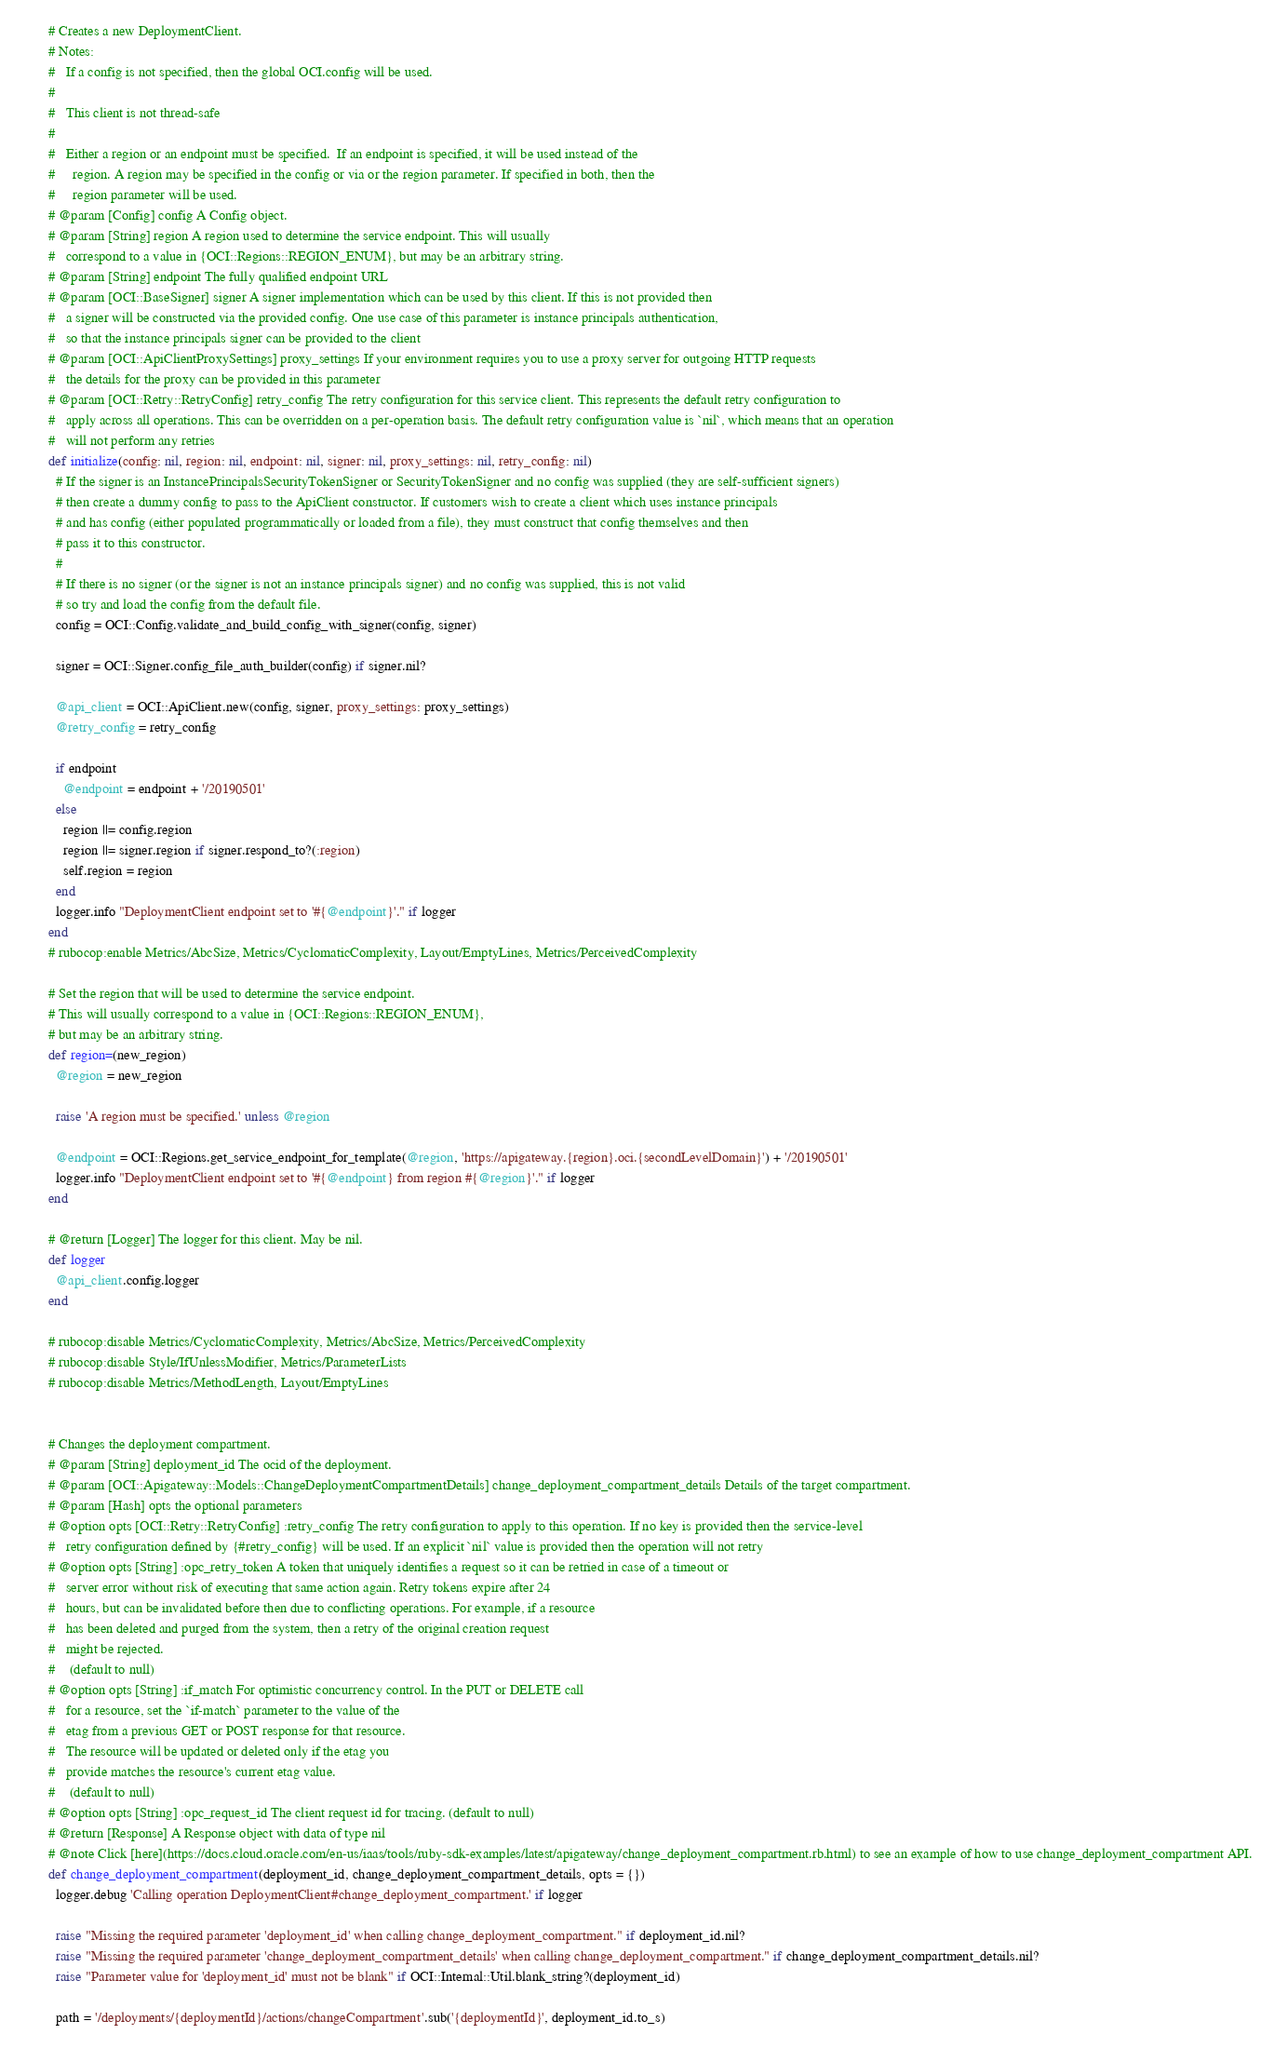Convert code to text. <code><loc_0><loc_0><loc_500><loc_500><_Ruby_>
    # Creates a new DeploymentClient.
    # Notes:
    #   If a config is not specified, then the global OCI.config will be used.
    #
    #   This client is not thread-safe
    #
    #   Either a region or an endpoint must be specified.  If an endpoint is specified, it will be used instead of the
    #     region. A region may be specified in the config or via or the region parameter. If specified in both, then the
    #     region parameter will be used.
    # @param [Config] config A Config object.
    # @param [String] region A region used to determine the service endpoint. This will usually
    #   correspond to a value in {OCI::Regions::REGION_ENUM}, but may be an arbitrary string.
    # @param [String] endpoint The fully qualified endpoint URL
    # @param [OCI::BaseSigner] signer A signer implementation which can be used by this client. If this is not provided then
    #   a signer will be constructed via the provided config. One use case of this parameter is instance principals authentication,
    #   so that the instance principals signer can be provided to the client
    # @param [OCI::ApiClientProxySettings] proxy_settings If your environment requires you to use a proxy server for outgoing HTTP requests
    #   the details for the proxy can be provided in this parameter
    # @param [OCI::Retry::RetryConfig] retry_config The retry configuration for this service client. This represents the default retry configuration to
    #   apply across all operations. This can be overridden on a per-operation basis. The default retry configuration value is `nil`, which means that an operation
    #   will not perform any retries
    def initialize(config: nil, region: nil, endpoint: nil, signer: nil, proxy_settings: nil, retry_config: nil)
      # If the signer is an InstancePrincipalsSecurityTokenSigner or SecurityTokenSigner and no config was supplied (they are self-sufficient signers)
      # then create a dummy config to pass to the ApiClient constructor. If customers wish to create a client which uses instance principals
      # and has config (either populated programmatically or loaded from a file), they must construct that config themselves and then
      # pass it to this constructor.
      #
      # If there is no signer (or the signer is not an instance principals signer) and no config was supplied, this is not valid
      # so try and load the config from the default file.
      config = OCI::Config.validate_and_build_config_with_signer(config, signer)

      signer = OCI::Signer.config_file_auth_builder(config) if signer.nil?

      @api_client = OCI::ApiClient.new(config, signer, proxy_settings: proxy_settings)
      @retry_config = retry_config

      if endpoint
        @endpoint = endpoint + '/20190501'
      else
        region ||= config.region
        region ||= signer.region if signer.respond_to?(:region)
        self.region = region
      end
      logger.info "DeploymentClient endpoint set to '#{@endpoint}'." if logger
    end
    # rubocop:enable Metrics/AbcSize, Metrics/CyclomaticComplexity, Layout/EmptyLines, Metrics/PerceivedComplexity

    # Set the region that will be used to determine the service endpoint.
    # This will usually correspond to a value in {OCI::Regions::REGION_ENUM},
    # but may be an arbitrary string.
    def region=(new_region)
      @region = new_region

      raise 'A region must be specified.' unless @region

      @endpoint = OCI::Regions.get_service_endpoint_for_template(@region, 'https://apigateway.{region}.oci.{secondLevelDomain}') + '/20190501'
      logger.info "DeploymentClient endpoint set to '#{@endpoint} from region #{@region}'." if logger
    end

    # @return [Logger] The logger for this client. May be nil.
    def logger
      @api_client.config.logger
    end

    # rubocop:disable Metrics/CyclomaticComplexity, Metrics/AbcSize, Metrics/PerceivedComplexity
    # rubocop:disable Style/IfUnlessModifier, Metrics/ParameterLists
    # rubocop:disable Metrics/MethodLength, Layout/EmptyLines


    # Changes the deployment compartment.
    # @param [String] deployment_id The ocid of the deployment.
    # @param [OCI::Apigateway::Models::ChangeDeploymentCompartmentDetails] change_deployment_compartment_details Details of the target compartment.
    # @param [Hash] opts the optional parameters
    # @option opts [OCI::Retry::RetryConfig] :retry_config The retry configuration to apply to this operation. If no key is provided then the service-level
    #   retry configuration defined by {#retry_config} will be used. If an explicit `nil` value is provided then the operation will not retry
    # @option opts [String] :opc_retry_token A token that uniquely identifies a request so it can be retried in case of a timeout or
    #   server error without risk of executing that same action again. Retry tokens expire after 24
    #   hours, but can be invalidated before then due to conflicting operations. For example, if a resource
    #   has been deleted and purged from the system, then a retry of the original creation request
    #   might be rejected.
    #    (default to null)
    # @option opts [String] :if_match For optimistic concurrency control. In the PUT or DELETE call
    #   for a resource, set the `if-match` parameter to the value of the
    #   etag from a previous GET or POST response for that resource.
    #   The resource will be updated or deleted only if the etag you
    #   provide matches the resource's current etag value.
    #    (default to null)
    # @option opts [String] :opc_request_id The client request id for tracing. (default to null)
    # @return [Response] A Response object with data of type nil
    # @note Click [here](https://docs.cloud.oracle.com/en-us/iaas/tools/ruby-sdk-examples/latest/apigateway/change_deployment_compartment.rb.html) to see an example of how to use change_deployment_compartment API.
    def change_deployment_compartment(deployment_id, change_deployment_compartment_details, opts = {})
      logger.debug 'Calling operation DeploymentClient#change_deployment_compartment.' if logger

      raise "Missing the required parameter 'deployment_id' when calling change_deployment_compartment." if deployment_id.nil?
      raise "Missing the required parameter 'change_deployment_compartment_details' when calling change_deployment_compartment." if change_deployment_compartment_details.nil?
      raise "Parameter value for 'deployment_id' must not be blank" if OCI::Internal::Util.blank_string?(deployment_id)

      path = '/deployments/{deploymentId}/actions/changeCompartment'.sub('{deploymentId}', deployment_id.to_s)</code> 